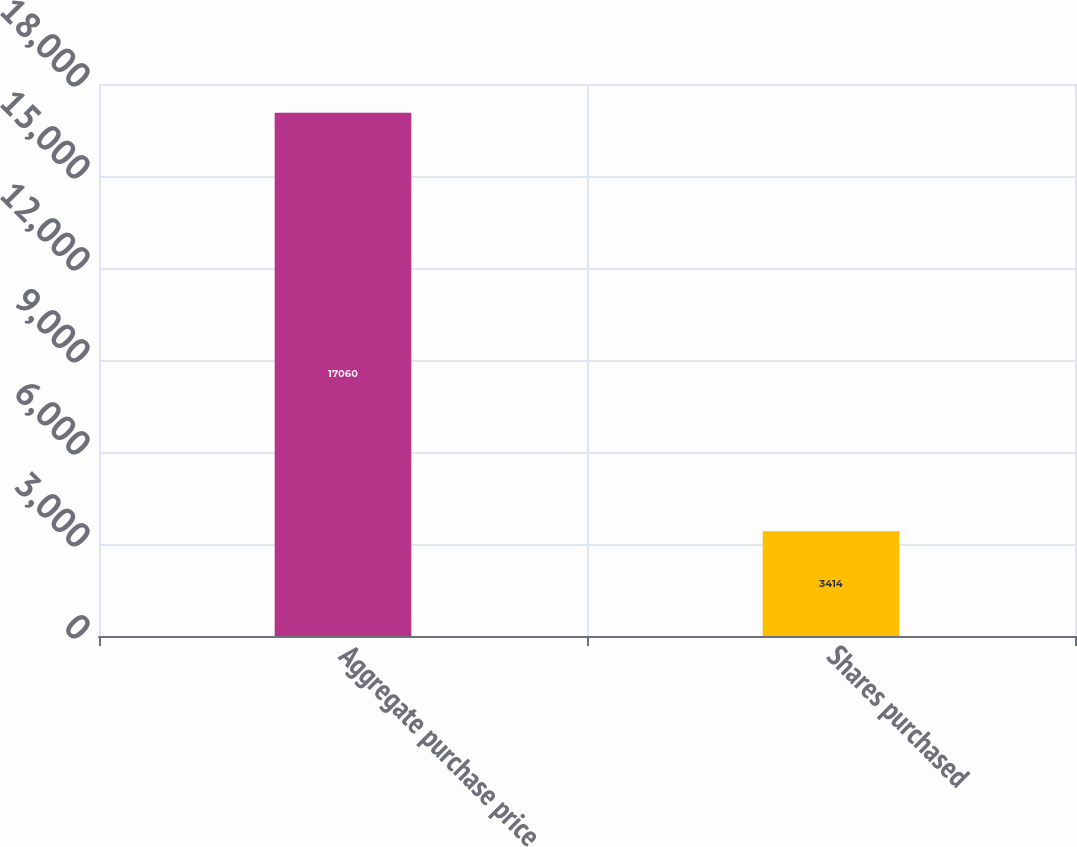<chart> <loc_0><loc_0><loc_500><loc_500><bar_chart><fcel>Aggregate purchase price<fcel>Shares purchased<nl><fcel>17060<fcel>3414<nl></chart> 